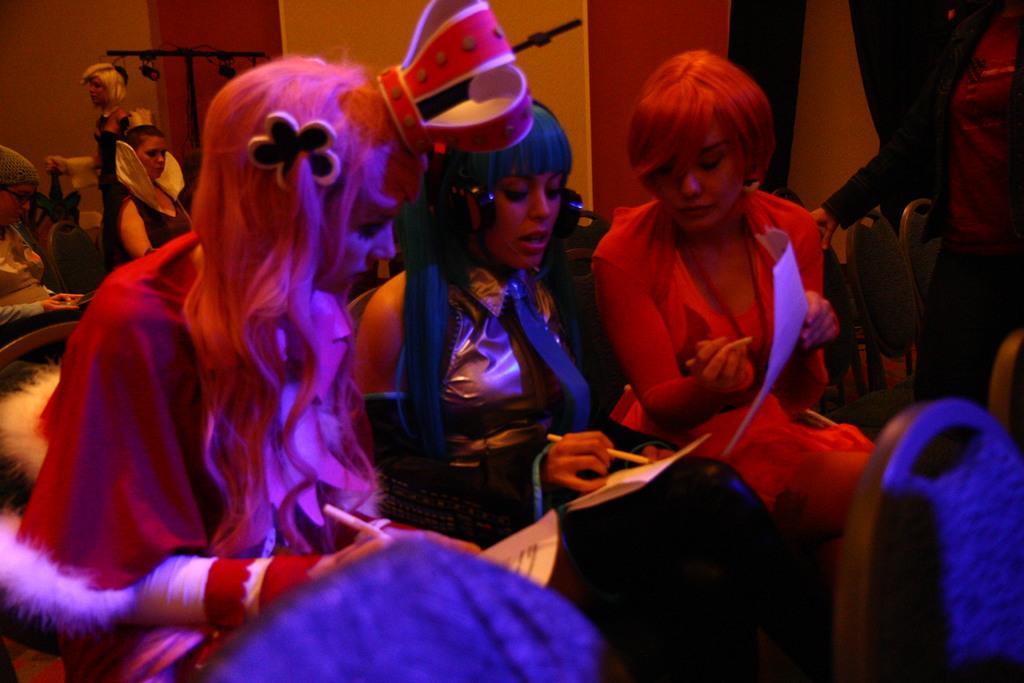In one or two sentences, can you explain what this image depicts? There are people sitting and wore fancy dresses and holding papers and pens and we can see chairs. In the background we can see wall,people and stand. 